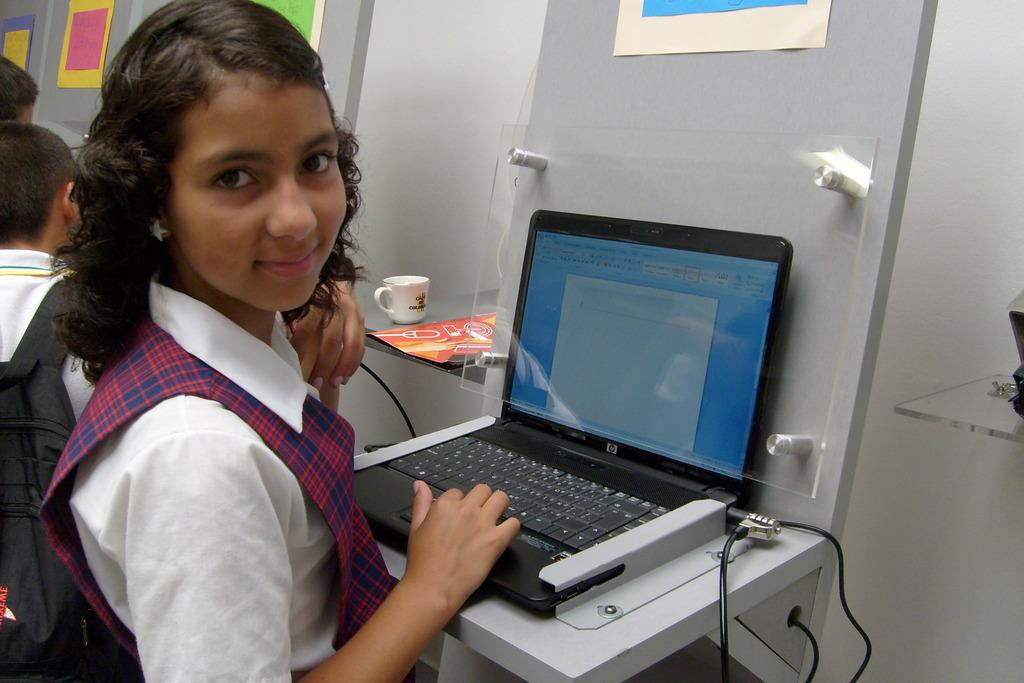<image>
Share a concise interpretation of the image provided. A young girl sitting in front of an HP laptop. 